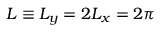<formula> <loc_0><loc_0><loc_500><loc_500>L \equiv L _ { y } = 2 L _ { x } = 2 \pi</formula> 